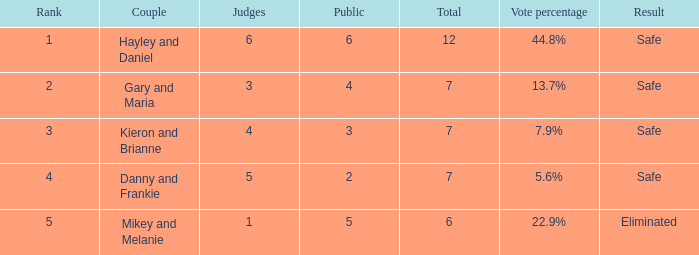What was the result for the total of 12? Safe. 